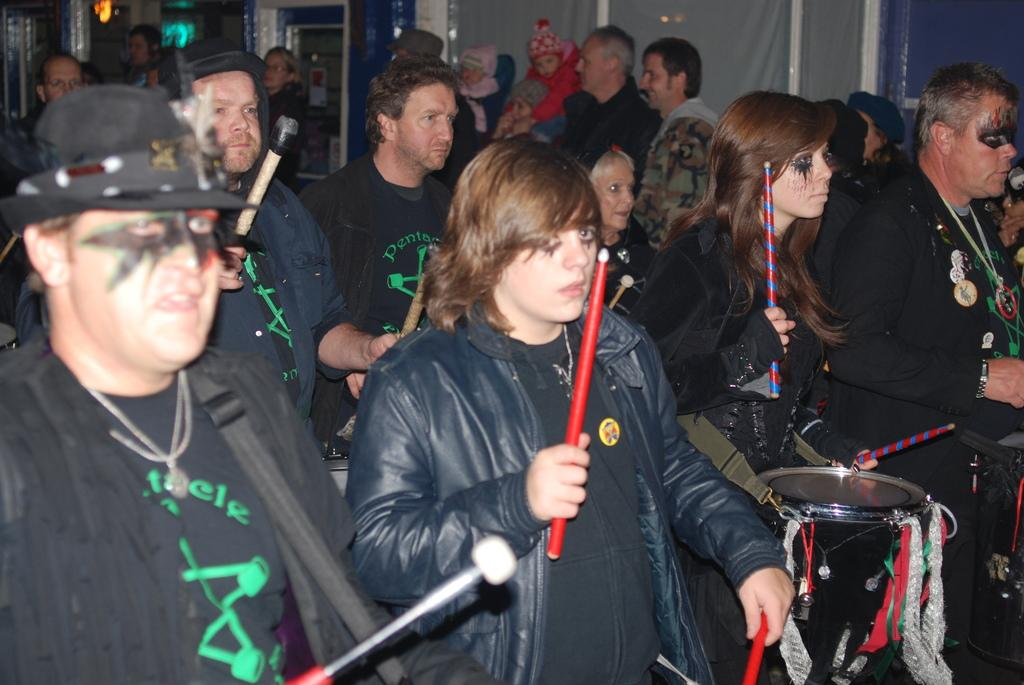What activity are the people in the image engaged in? The people in the image are playing drums. What are the people holding in their hands? The people are holding sticks in their hands. Can you describe the composition of the group? There are both men and women in the group. Are there any other people visible in the image? Yes, there are people standing in the background of the image. What condition is the governor in during the drum performance? There is no governor present in the image, so it is not possible to determine their condition during the drum performance. 